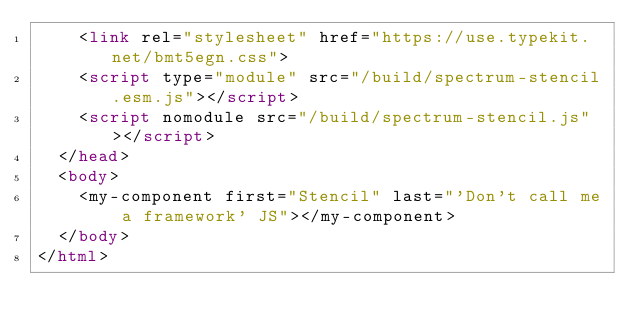<code> <loc_0><loc_0><loc_500><loc_500><_HTML_>    <link rel="stylesheet" href="https://use.typekit.net/bmt5egn.css">
    <script type="module" src="/build/spectrum-stencil.esm.js"></script>
    <script nomodule src="/build/spectrum-stencil.js"></script>
  </head>
  <body>
    <my-component first="Stencil" last="'Don't call me a framework' JS"></my-component>
  </body>
</html>
</code> 